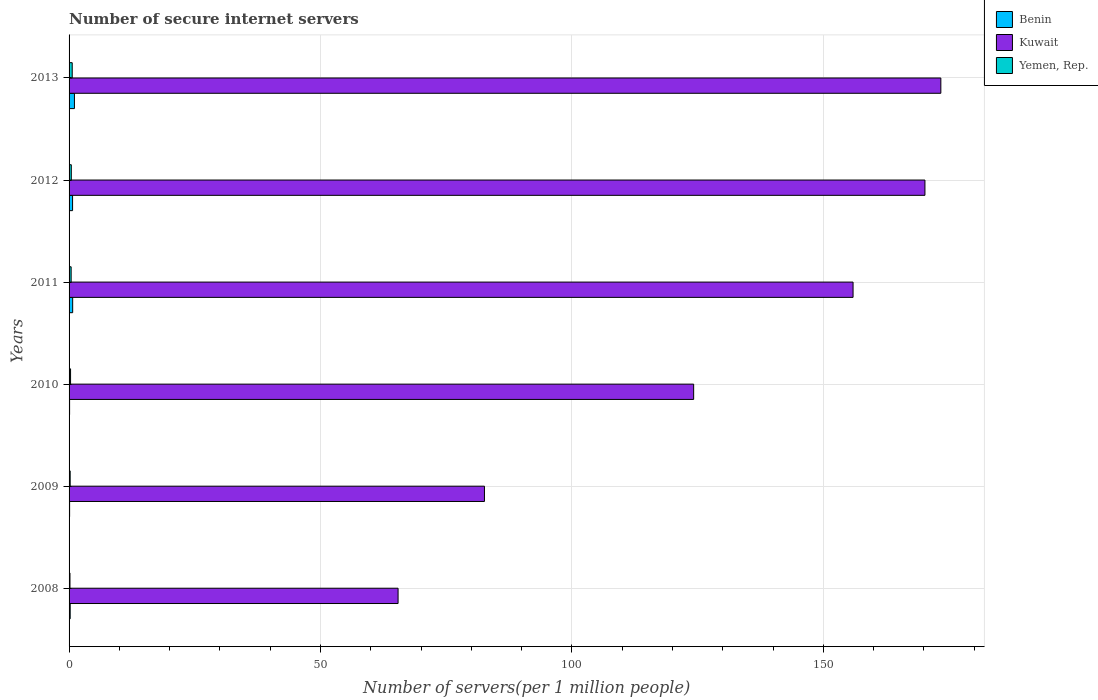How many different coloured bars are there?
Your response must be concise. 3. How many bars are there on the 6th tick from the top?
Offer a terse response. 3. What is the number of secure internet servers in Benin in 2009?
Your answer should be very brief. 0.11. Across all years, what is the maximum number of secure internet servers in Yemen, Rep.?
Keep it short and to the point. 0.63. Across all years, what is the minimum number of secure internet servers in Benin?
Offer a terse response. 0.11. In which year was the number of secure internet servers in Benin maximum?
Provide a short and direct response. 2013. In which year was the number of secure internet servers in Kuwait minimum?
Give a very brief answer. 2008. What is the total number of secure internet servers in Kuwait in the graph?
Provide a short and direct response. 771.69. What is the difference between the number of secure internet servers in Yemen, Rep. in 2010 and that in 2012?
Provide a short and direct response. -0.15. What is the difference between the number of secure internet servers in Benin in 2009 and the number of secure internet servers in Yemen, Rep. in 2012?
Keep it short and to the point. -0.33. What is the average number of secure internet servers in Kuwait per year?
Your answer should be very brief. 128.62. In the year 2008, what is the difference between the number of secure internet servers in Benin and number of secure internet servers in Yemen, Rep.?
Keep it short and to the point. 0.04. In how many years, is the number of secure internet servers in Benin greater than 70 ?
Provide a short and direct response. 0. What is the ratio of the number of secure internet servers in Kuwait in 2008 to that in 2009?
Offer a terse response. 0.79. Is the number of secure internet servers in Yemen, Rep. in 2010 less than that in 2012?
Provide a short and direct response. Yes. Is the difference between the number of secure internet servers in Benin in 2008 and 2012 greater than the difference between the number of secure internet servers in Yemen, Rep. in 2008 and 2012?
Provide a short and direct response. No. What is the difference between the highest and the second highest number of secure internet servers in Yemen, Rep.?
Keep it short and to the point. 0.18. What is the difference between the highest and the lowest number of secure internet servers in Kuwait?
Keep it short and to the point. 107.93. Is the sum of the number of secure internet servers in Kuwait in 2011 and 2012 greater than the maximum number of secure internet servers in Benin across all years?
Give a very brief answer. Yes. What does the 1st bar from the top in 2012 represents?
Provide a succinct answer. Yemen, Rep. What does the 1st bar from the bottom in 2011 represents?
Offer a very short reply. Benin. How many bars are there?
Provide a succinct answer. 18. Are all the bars in the graph horizontal?
Your answer should be very brief. Yes. How many years are there in the graph?
Offer a terse response. 6. What is the difference between two consecutive major ticks on the X-axis?
Your answer should be very brief. 50. Does the graph contain any zero values?
Your answer should be compact. No. How many legend labels are there?
Offer a terse response. 3. How are the legend labels stacked?
Offer a very short reply. Vertical. What is the title of the graph?
Your response must be concise. Number of secure internet servers. Does "Costa Rica" appear as one of the legend labels in the graph?
Ensure brevity in your answer.  No. What is the label or title of the X-axis?
Your response must be concise. Number of servers(per 1 million people). What is the label or title of the Y-axis?
Your answer should be very brief. Years. What is the Number of servers(per 1 million people) in Benin in 2008?
Give a very brief answer. 0.22. What is the Number of servers(per 1 million people) in Kuwait in 2008?
Ensure brevity in your answer.  65.43. What is the Number of servers(per 1 million people) in Yemen, Rep. in 2008?
Offer a very short reply. 0.18. What is the Number of servers(per 1 million people) in Benin in 2009?
Keep it short and to the point. 0.11. What is the Number of servers(per 1 million people) of Kuwait in 2009?
Your answer should be compact. 82.6. What is the Number of servers(per 1 million people) of Yemen, Rep. in 2009?
Your answer should be very brief. 0.22. What is the Number of servers(per 1 million people) in Benin in 2010?
Give a very brief answer. 0.11. What is the Number of servers(per 1 million people) in Kuwait in 2010?
Your response must be concise. 124.2. What is the Number of servers(per 1 million people) in Yemen, Rep. in 2010?
Ensure brevity in your answer.  0.3. What is the Number of servers(per 1 million people) of Benin in 2011?
Give a very brief answer. 0.72. What is the Number of servers(per 1 million people) of Kuwait in 2011?
Provide a short and direct response. 155.9. What is the Number of servers(per 1 million people) in Yemen, Rep. in 2011?
Provide a short and direct response. 0.41. What is the Number of servers(per 1 million people) of Benin in 2012?
Offer a terse response. 0.7. What is the Number of servers(per 1 million people) of Kuwait in 2012?
Give a very brief answer. 170.2. What is the Number of servers(per 1 million people) of Yemen, Rep. in 2012?
Offer a terse response. 0.44. What is the Number of servers(per 1 million people) of Benin in 2013?
Make the answer very short. 1.07. What is the Number of servers(per 1 million people) in Kuwait in 2013?
Make the answer very short. 173.36. What is the Number of servers(per 1 million people) of Yemen, Rep. in 2013?
Offer a very short reply. 0.63. Across all years, what is the maximum Number of servers(per 1 million people) of Benin?
Ensure brevity in your answer.  1.07. Across all years, what is the maximum Number of servers(per 1 million people) in Kuwait?
Make the answer very short. 173.36. Across all years, what is the maximum Number of servers(per 1 million people) of Yemen, Rep.?
Your response must be concise. 0.63. Across all years, what is the minimum Number of servers(per 1 million people) of Benin?
Ensure brevity in your answer.  0.11. Across all years, what is the minimum Number of servers(per 1 million people) in Kuwait?
Provide a short and direct response. 65.43. Across all years, what is the minimum Number of servers(per 1 million people) of Yemen, Rep.?
Offer a very short reply. 0.18. What is the total Number of servers(per 1 million people) in Benin in the graph?
Ensure brevity in your answer.  2.91. What is the total Number of servers(per 1 million people) of Kuwait in the graph?
Provide a succinct answer. 771.69. What is the total Number of servers(per 1 million people) in Yemen, Rep. in the graph?
Offer a very short reply. 2.18. What is the difference between the Number of servers(per 1 million people) of Benin in 2008 and that in 2009?
Keep it short and to the point. 0.11. What is the difference between the Number of servers(per 1 million people) in Kuwait in 2008 and that in 2009?
Your answer should be compact. -17.18. What is the difference between the Number of servers(per 1 million people) of Yemen, Rep. in 2008 and that in 2009?
Provide a short and direct response. -0.04. What is the difference between the Number of servers(per 1 million people) of Benin in 2008 and that in 2010?
Make the answer very short. 0.12. What is the difference between the Number of servers(per 1 million people) of Kuwait in 2008 and that in 2010?
Keep it short and to the point. -58.78. What is the difference between the Number of servers(per 1 million people) of Yemen, Rep. in 2008 and that in 2010?
Keep it short and to the point. -0.12. What is the difference between the Number of servers(per 1 million people) in Benin in 2008 and that in 2011?
Make the answer very short. -0.49. What is the difference between the Number of servers(per 1 million people) of Kuwait in 2008 and that in 2011?
Ensure brevity in your answer.  -90.48. What is the difference between the Number of servers(per 1 million people) in Yemen, Rep. in 2008 and that in 2011?
Provide a short and direct response. -0.23. What is the difference between the Number of servers(per 1 million people) of Benin in 2008 and that in 2012?
Provide a short and direct response. -0.47. What is the difference between the Number of servers(per 1 million people) in Kuwait in 2008 and that in 2012?
Your answer should be very brief. -104.77. What is the difference between the Number of servers(per 1 million people) of Yemen, Rep. in 2008 and that in 2012?
Your answer should be compact. -0.26. What is the difference between the Number of servers(per 1 million people) in Benin in 2008 and that in 2013?
Give a very brief answer. -0.84. What is the difference between the Number of servers(per 1 million people) of Kuwait in 2008 and that in 2013?
Your response must be concise. -107.93. What is the difference between the Number of servers(per 1 million people) in Yemen, Rep. in 2008 and that in 2013?
Offer a terse response. -0.45. What is the difference between the Number of servers(per 1 million people) of Benin in 2009 and that in 2010?
Your answer should be very brief. 0. What is the difference between the Number of servers(per 1 million people) in Kuwait in 2009 and that in 2010?
Make the answer very short. -41.6. What is the difference between the Number of servers(per 1 million people) in Yemen, Rep. in 2009 and that in 2010?
Give a very brief answer. -0.08. What is the difference between the Number of servers(per 1 million people) in Benin in 2009 and that in 2011?
Offer a terse response. -0.61. What is the difference between the Number of servers(per 1 million people) of Kuwait in 2009 and that in 2011?
Make the answer very short. -73.3. What is the difference between the Number of servers(per 1 million people) in Yemen, Rep. in 2009 and that in 2011?
Ensure brevity in your answer.  -0.19. What is the difference between the Number of servers(per 1 million people) of Benin in 2009 and that in 2012?
Provide a short and direct response. -0.59. What is the difference between the Number of servers(per 1 million people) of Kuwait in 2009 and that in 2012?
Your response must be concise. -87.59. What is the difference between the Number of servers(per 1 million people) of Yemen, Rep. in 2009 and that in 2012?
Keep it short and to the point. -0.22. What is the difference between the Number of servers(per 1 million people) of Benin in 2009 and that in 2013?
Provide a succinct answer. -0.96. What is the difference between the Number of servers(per 1 million people) of Kuwait in 2009 and that in 2013?
Your answer should be very brief. -90.76. What is the difference between the Number of servers(per 1 million people) in Yemen, Rep. in 2009 and that in 2013?
Provide a short and direct response. -0.41. What is the difference between the Number of servers(per 1 million people) of Benin in 2010 and that in 2011?
Make the answer very short. -0.61. What is the difference between the Number of servers(per 1 million people) of Kuwait in 2010 and that in 2011?
Ensure brevity in your answer.  -31.7. What is the difference between the Number of servers(per 1 million people) in Yemen, Rep. in 2010 and that in 2011?
Your answer should be very brief. -0.12. What is the difference between the Number of servers(per 1 million people) in Benin in 2010 and that in 2012?
Offer a very short reply. -0.59. What is the difference between the Number of servers(per 1 million people) in Kuwait in 2010 and that in 2012?
Your response must be concise. -45.99. What is the difference between the Number of servers(per 1 million people) in Yemen, Rep. in 2010 and that in 2012?
Provide a succinct answer. -0.15. What is the difference between the Number of servers(per 1 million people) in Benin in 2010 and that in 2013?
Ensure brevity in your answer.  -0.96. What is the difference between the Number of servers(per 1 million people) of Kuwait in 2010 and that in 2013?
Your answer should be very brief. -49.16. What is the difference between the Number of servers(per 1 million people) in Yemen, Rep. in 2010 and that in 2013?
Provide a short and direct response. -0.33. What is the difference between the Number of servers(per 1 million people) of Benin in 2011 and that in 2012?
Ensure brevity in your answer.  0.02. What is the difference between the Number of servers(per 1 million people) of Kuwait in 2011 and that in 2012?
Your answer should be very brief. -14.29. What is the difference between the Number of servers(per 1 million people) of Yemen, Rep. in 2011 and that in 2012?
Your answer should be very brief. -0.03. What is the difference between the Number of servers(per 1 million people) of Benin in 2011 and that in 2013?
Give a very brief answer. -0.35. What is the difference between the Number of servers(per 1 million people) in Kuwait in 2011 and that in 2013?
Your answer should be compact. -17.46. What is the difference between the Number of servers(per 1 million people) of Yemen, Rep. in 2011 and that in 2013?
Your answer should be very brief. -0.21. What is the difference between the Number of servers(per 1 million people) in Benin in 2012 and that in 2013?
Keep it short and to the point. -0.37. What is the difference between the Number of servers(per 1 million people) of Kuwait in 2012 and that in 2013?
Ensure brevity in your answer.  -3.16. What is the difference between the Number of servers(per 1 million people) in Yemen, Rep. in 2012 and that in 2013?
Make the answer very short. -0.18. What is the difference between the Number of servers(per 1 million people) in Benin in 2008 and the Number of servers(per 1 million people) in Kuwait in 2009?
Your answer should be very brief. -82.38. What is the difference between the Number of servers(per 1 million people) of Benin in 2008 and the Number of servers(per 1 million people) of Yemen, Rep. in 2009?
Provide a short and direct response. 0.01. What is the difference between the Number of servers(per 1 million people) of Kuwait in 2008 and the Number of servers(per 1 million people) of Yemen, Rep. in 2009?
Your response must be concise. 65.21. What is the difference between the Number of servers(per 1 million people) in Benin in 2008 and the Number of servers(per 1 million people) in Kuwait in 2010?
Provide a succinct answer. -123.98. What is the difference between the Number of servers(per 1 million people) of Benin in 2008 and the Number of servers(per 1 million people) of Yemen, Rep. in 2010?
Ensure brevity in your answer.  -0.07. What is the difference between the Number of servers(per 1 million people) in Kuwait in 2008 and the Number of servers(per 1 million people) in Yemen, Rep. in 2010?
Offer a very short reply. 65.13. What is the difference between the Number of servers(per 1 million people) of Benin in 2008 and the Number of servers(per 1 million people) of Kuwait in 2011?
Keep it short and to the point. -155.68. What is the difference between the Number of servers(per 1 million people) in Benin in 2008 and the Number of servers(per 1 million people) in Yemen, Rep. in 2011?
Keep it short and to the point. -0.19. What is the difference between the Number of servers(per 1 million people) in Kuwait in 2008 and the Number of servers(per 1 million people) in Yemen, Rep. in 2011?
Keep it short and to the point. 65.01. What is the difference between the Number of servers(per 1 million people) of Benin in 2008 and the Number of servers(per 1 million people) of Kuwait in 2012?
Make the answer very short. -169.97. What is the difference between the Number of servers(per 1 million people) in Benin in 2008 and the Number of servers(per 1 million people) in Yemen, Rep. in 2012?
Provide a succinct answer. -0.22. What is the difference between the Number of servers(per 1 million people) in Kuwait in 2008 and the Number of servers(per 1 million people) in Yemen, Rep. in 2012?
Provide a short and direct response. 64.99. What is the difference between the Number of servers(per 1 million people) of Benin in 2008 and the Number of servers(per 1 million people) of Kuwait in 2013?
Offer a very short reply. -173.14. What is the difference between the Number of servers(per 1 million people) of Benin in 2008 and the Number of servers(per 1 million people) of Yemen, Rep. in 2013?
Offer a very short reply. -0.4. What is the difference between the Number of servers(per 1 million people) in Kuwait in 2008 and the Number of servers(per 1 million people) in Yemen, Rep. in 2013?
Give a very brief answer. 64.8. What is the difference between the Number of servers(per 1 million people) of Benin in 2009 and the Number of servers(per 1 million people) of Kuwait in 2010?
Your response must be concise. -124.1. What is the difference between the Number of servers(per 1 million people) of Benin in 2009 and the Number of servers(per 1 million people) of Yemen, Rep. in 2010?
Your response must be concise. -0.19. What is the difference between the Number of servers(per 1 million people) in Kuwait in 2009 and the Number of servers(per 1 million people) in Yemen, Rep. in 2010?
Ensure brevity in your answer.  82.31. What is the difference between the Number of servers(per 1 million people) in Benin in 2009 and the Number of servers(per 1 million people) in Kuwait in 2011?
Ensure brevity in your answer.  -155.8. What is the difference between the Number of servers(per 1 million people) in Benin in 2009 and the Number of servers(per 1 million people) in Yemen, Rep. in 2011?
Keep it short and to the point. -0.3. What is the difference between the Number of servers(per 1 million people) of Kuwait in 2009 and the Number of servers(per 1 million people) of Yemen, Rep. in 2011?
Your response must be concise. 82.19. What is the difference between the Number of servers(per 1 million people) in Benin in 2009 and the Number of servers(per 1 million people) in Kuwait in 2012?
Ensure brevity in your answer.  -170.09. What is the difference between the Number of servers(per 1 million people) in Benin in 2009 and the Number of servers(per 1 million people) in Yemen, Rep. in 2012?
Provide a succinct answer. -0.33. What is the difference between the Number of servers(per 1 million people) in Kuwait in 2009 and the Number of servers(per 1 million people) in Yemen, Rep. in 2012?
Make the answer very short. 82.16. What is the difference between the Number of servers(per 1 million people) of Benin in 2009 and the Number of servers(per 1 million people) of Kuwait in 2013?
Offer a terse response. -173.25. What is the difference between the Number of servers(per 1 million people) in Benin in 2009 and the Number of servers(per 1 million people) in Yemen, Rep. in 2013?
Your answer should be compact. -0.52. What is the difference between the Number of servers(per 1 million people) of Kuwait in 2009 and the Number of servers(per 1 million people) of Yemen, Rep. in 2013?
Offer a very short reply. 81.98. What is the difference between the Number of servers(per 1 million people) in Benin in 2010 and the Number of servers(per 1 million people) in Kuwait in 2011?
Provide a succinct answer. -155.8. What is the difference between the Number of servers(per 1 million people) of Benin in 2010 and the Number of servers(per 1 million people) of Yemen, Rep. in 2011?
Keep it short and to the point. -0.31. What is the difference between the Number of servers(per 1 million people) in Kuwait in 2010 and the Number of servers(per 1 million people) in Yemen, Rep. in 2011?
Make the answer very short. 123.79. What is the difference between the Number of servers(per 1 million people) in Benin in 2010 and the Number of servers(per 1 million people) in Kuwait in 2012?
Offer a very short reply. -170.09. What is the difference between the Number of servers(per 1 million people) in Benin in 2010 and the Number of servers(per 1 million people) in Yemen, Rep. in 2012?
Make the answer very short. -0.34. What is the difference between the Number of servers(per 1 million people) of Kuwait in 2010 and the Number of servers(per 1 million people) of Yemen, Rep. in 2012?
Your answer should be very brief. 123.76. What is the difference between the Number of servers(per 1 million people) of Benin in 2010 and the Number of servers(per 1 million people) of Kuwait in 2013?
Your answer should be compact. -173.25. What is the difference between the Number of servers(per 1 million people) of Benin in 2010 and the Number of servers(per 1 million people) of Yemen, Rep. in 2013?
Your answer should be compact. -0.52. What is the difference between the Number of servers(per 1 million people) of Kuwait in 2010 and the Number of servers(per 1 million people) of Yemen, Rep. in 2013?
Provide a succinct answer. 123.58. What is the difference between the Number of servers(per 1 million people) of Benin in 2011 and the Number of servers(per 1 million people) of Kuwait in 2012?
Provide a short and direct response. -169.48. What is the difference between the Number of servers(per 1 million people) of Benin in 2011 and the Number of servers(per 1 million people) of Yemen, Rep. in 2012?
Offer a very short reply. 0.27. What is the difference between the Number of servers(per 1 million people) in Kuwait in 2011 and the Number of servers(per 1 million people) in Yemen, Rep. in 2012?
Make the answer very short. 155.46. What is the difference between the Number of servers(per 1 million people) in Benin in 2011 and the Number of servers(per 1 million people) in Kuwait in 2013?
Offer a very short reply. -172.64. What is the difference between the Number of servers(per 1 million people) of Benin in 2011 and the Number of servers(per 1 million people) of Yemen, Rep. in 2013?
Ensure brevity in your answer.  0.09. What is the difference between the Number of servers(per 1 million people) in Kuwait in 2011 and the Number of servers(per 1 million people) in Yemen, Rep. in 2013?
Your answer should be very brief. 155.28. What is the difference between the Number of servers(per 1 million people) of Benin in 2012 and the Number of servers(per 1 million people) of Kuwait in 2013?
Keep it short and to the point. -172.66. What is the difference between the Number of servers(per 1 million people) in Benin in 2012 and the Number of servers(per 1 million people) in Yemen, Rep. in 2013?
Make the answer very short. 0.07. What is the difference between the Number of servers(per 1 million people) of Kuwait in 2012 and the Number of servers(per 1 million people) of Yemen, Rep. in 2013?
Give a very brief answer. 169.57. What is the average Number of servers(per 1 million people) in Benin per year?
Offer a terse response. 0.49. What is the average Number of servers(per 1 million people) in Kuwait per year?
Provide a succinct answer. 128.62. What is the average Number of servers(per 1 million people) of Yemen, Rep. per year?
Offer a terse response. 0.36. In the year 2008, what is the difference between the Number of servers(per 1 million people) in Benin and Number of servers(per 1 million people) in Kuwait?
Provide a short and direct response. -65.2. In the year 2008, what is the difference between the Number of servers(per 1 million people) in Benin and Number of servers(per 1 million people) in Yemen, Rep.?
Offer a very short reply. 0.04. In the year 2008, what is the difference between the Number of servers(per 1 million people) in Kuwait and Number of servers(per 1 million people) in Yemen, Rep.?
Your response must be concise. 65.25. In the year 2009, what is the difference between the Number of servers(per 1 million people) of Benin and Number of servers(per 1 million people) of Kuwait?
Keep it short and to the point. -82.5. In the year 2009, what is the difference between the Number of servers(per 1 million people) of Benin and Number of servers(per 1 million people) of Yemen, Rep.?
Your answer should be very brief. -0.11. In the year 2009, what is the difference between the Number of servers(per 1 million people) of Kuwait and Number of servers(per 1 million people) of Yemen, Rep.?
Provide a short and direct response. 82.39. In the year 2010, what is the difference between the Number of servers(per 1 million people) in Benin and Number of servers(per 1 million people) in Kuwait?
Give a very brief answer. -124.1. In the year 2010, what is the difference between the Number of servers(per 1 million people) in Benin and Number of servers(per 1 million people) in Yemen, Rep.?
Give a very brief answer. -0.19. In the year 2010, what is the difference between the Number of servers(per 1 million people) of Kuwait and Number of servers(per 1 million people) of Yemen, Rep.?
Keep it short and to the point. 123.91. In the year 2011, what is the difference between the Number of servers(per 1 million people) in Benin and Number of servers(per 1 million people) in Kuwait?
Provide a short and direct response. -155.19. In the year 2011, what is the difference between the Number of servers(per 1 million people) in Benin and Number of servers(per 1 million people) in Yemen, Rep.?
Your answer should be compact. 0.3. In the year 2011, what is the difference between the Number of servers(per 1 million people) of Kuwait and Number of servers(per 1 million people) of Yemen, Rep.?
Provide a short and direct response. 155.49. In the year 2012, what is the difference between the Number of servers(per 1 million people) in Benin and Number of servers(per 1 million people) in Kuwait?
Provide a short and direct response. -169.5. In the year 2012, what is the difference between the Number of servers(per 1 million people) of Benin and Number of servers(per 1 million people) of Yemen, Rep.?
Provide a short and direct response. 0.25. In the year 2012, what is the difference between the Number of servers(per 1 million people) in Kuwait and Number of servers(per 1 million people) in Yemen, Rep.?
Your answer should be very brief. 169.75. In the year 2013, what is the difference between the Number of servers(per 1 million people) of Benin and Number of servers(per 1 million people) of Kuwait?
Your answer should be compact. -172.29. In the year 2013, what is the difference between the Number of servers(per 1 million people) of Benin and Number of servers(per 1 million people) of Yemen, Rep.?
Your answer should be compact. 0.44. In the year 2013, what is the difference between the Number of servers(per 1 million people) of Kuwait and Number of servers(per 1 million people) of Yemen, Rep.?
Your answer should be compact. 172.73. What is the ratio of the Number of servers(per 1 million people) in Benin in 2008 to that in 2009?
Ensure brevity in your answer.  2.06. What is the ratio of the Number of servers(per 1 million people) in Kuwait in 2008 to that in 2009?
Make the answer very short. 0.79. What is the ratio of the Number of servers(per 1 million people) of Yemen, Rep. in 2008 to that in 2009?
Provide a succinct answer. 0.82. What is the ratio of the Number of servers(per 1 million people) in Benin in 2008 to that in 2010?
Offer a terse response. 2.12. What is the ratio of the Number of servers(per 1 million people) of Kuwait in 2008 to that in 2010?
Offer a very short reply. 0.53. What is the ratio of the Number of servers(per 1 million people) in Yemen, Rep. in 2008 to that in 2010?
Offer a very short reply. 0.6. What is the ratio of the Number of servers(per 1 million people) in Benin in 2008 to that in 2011?
Make the answer very short. 0.31. What is the ratio of the Number of servers(per 1 million people) in Kuwait in 2008 to that in 2011?
Your answer should be very brief. 0.42. What is the ratio of the Number of servers(per 1 million people) in Yemen, Rep. in 2008 to that in 2011?
Provide a short and direct response. 0.43. What is the ratio of the Number of servers(per 1 million people) of Benin in 2008 to that in 2012?
Provide a short and direct response. 0.32. What is the ratio of the Number of servers(per 1 million people) in Kuwait in 2008 to that in 2012?
Your answer should be very brief. 0.38. What is the ratio of the Number of servers(per 1 million people) in Yemen, Rep. in 2008 to that in 2012?
Keep it short and to the point. 0.41. What is the ratio of the Number of servers(per 1 million people) in Benin in 2008 to that in 2013?
Ensure brevity in your answer.  0.21. What is the ratio of the Number of servers(per 1 million people) in Kuwait in 2008 to that in 2013?
Your answer should be compact. 0.38. What is the ratio of the Number of servers(per 1 million people) of Yemen, Rep. in 2008 to that in 2013?
Offer a very short reply. 0.29. What is the ratio of the Number of servers(per 1 million people) of Benin in 2009 to that in 2010?
Make the answer very short. 1.03. What is the ratio of the Number of servers(per 1 million people) in Kuwait in 2009 to that in 2010?
Give a very brief answer. 0.67. What is the ratio of the Number of servers(per 1 million people) in Yemen, Rep. in 2009 to that in 2010?
Provide a succinct answer. 0.73. What is the ratio of the Number of servers(per 1 million people) in Benin in 2009 to that in 2011?
Keep it short and to the point. 0.15. What is the ratio of the Number of servers(per 1 million people) in Kuwait in 2009 to that in 2011?
Your response must be concise. 0.53. What is the ratio of the Number of servers(per 1 million people) of Yemen, Rep. in 2009 to that in 2011?
Your answer should be very brief. 0.53. What is the ratio of the Number of servers(per 1 million people) in Benin in 2009 to that in 2012?
Your answer should be very brief. 0.16. What is the ratio of the Number of servers(per 1 million people) in Kuwait in 2009 to that in 2012?
Offer a very short reply. 0.49. What is the ratio of the Number of servers(per 1 million people) of Yemen, Rep. in 2009 to that in 2012?
Offer a terse response. 0.49. What is the ratio of the Number of servers(per 1 million people) in Benin in 2009 to that in 2013?
Your response must be concise. 0.1. What is the ratio of the Number of servers(per 1 million people) in Kuwait in 2009 to that in 2013?
Offer a very short reply. 0.48. What is the ratio of the Number of servers(per 1 million people) of Yemen, Rep. in 2009 to that in 2013?
Your answer should be very brief. 0.35. What is the ratio of the Number of servers(per 1 million people) of Benin in 2010 to that in 2011?
Your response must be concise. 0.15. What is the ratio of the Number of servers(per 1 million people) of Kuwait in 2010 to that in 2011?
Make the answer very short. 0.8. What is the ratio of the Number of servers(per 1 million people) in Yemen, Rep. in 2010 to that in 2011?
Keep it short and to the point. 0.72. What is the ratio of the Number of servers(per 1 million people) in Benin in 2010 to that in 2012?
Provide a succinct answer. 0.15. What is the ratio of the Number of servers(per 1 million people) in Kuwait in 2010 to that in 2012?
Ensure brevity in your answer.  0.73. What is the ratio of the Number of servers(per 1 million people) of Yemen, Rep. in 2010 to that in 2012?
Give a very brief answer. 0.67. What is the ratio of the Number of servers(per 1 million people) in Benin in 2010 to that in 2013?
Offer a terse response. 0.1. What is the ratio of the Number of servers(per 1 million people) of Kuwait in 2010 to that in 2013?
Your answer should be compact. 0.72. What is the ratio of the Number of servers(per 1 million people) in Yemen, Rep. in 2010 to that in 2013?
Make the answer very short. 0.47. What is the ratio of the Number of servers(per 1 million people) in Benin in 2011 to that in 2012?
Your answer should be very brief. 1.03. What is the ratio of the Number of servers(per 1 million people) in Kuwait in 2011 to that in 2012?
Keep it short and to the point. 0.92. What is the ratio of the Number of servers(per 1 million people) of Yemen, Rep. in 2011 to that in 2012?
Make the answer very short. 0.93. What is the ratio of the Number of servers(per 1 million people) in Benin in 2011 to that in 2013?
Make the answer very short. 0.67. What is the ratio of the Number of servers(per 1 million people) of Kuwait in 2011 to that in 2013?
Keep it short and to the point. 0.9. What is the ratio of the Number of servers(per 1 million people) in Yemen, Rep. in 2011 to that in 2013?
Provide a succinct answer. 0.66. What is the ratio of the Number of servers(per 1 million people) in Benin in 2012 to that in 2013?
Your answer should be very brief. 0.65. What is the ratio of the Number of servers(per 1 million people) in Kuwait in 2012 to that in 2013?
Provide a short and direct response. 0.98. What is the ratio of the Number of servers(per 1 million people) of Yemen, Rep. in 2012 to that in 2013?
Your answer should be compact. 0.71. What is the difference between the highest and the second highest Number of servers(per 1 million people) in Benin?
Offer a very short reply. 0.35. What is the difference between the highest and the second highest Number of servers(per 1 million people) in Kuwait?
Offer a terse response. 3.16. What is the difference between the highest and the second highest Number of servers(per 1 million people) in Yemen, Rep.?
Your response must be concise. 0.18. What is the difference between the highest and the lowest Number of servers(per 1 million people) of Benin?
Your answer should be compact. 0.96. What is the difference between the highest and the lowest Number of servers(per 1 million people) in Kuwait?
Provide a short and direct response. 107.93. What is the difference between the highest and the lowest Number of servers(per 1 million people) of Yemen, Rep.?
Give a very brief answer. 0.45. 